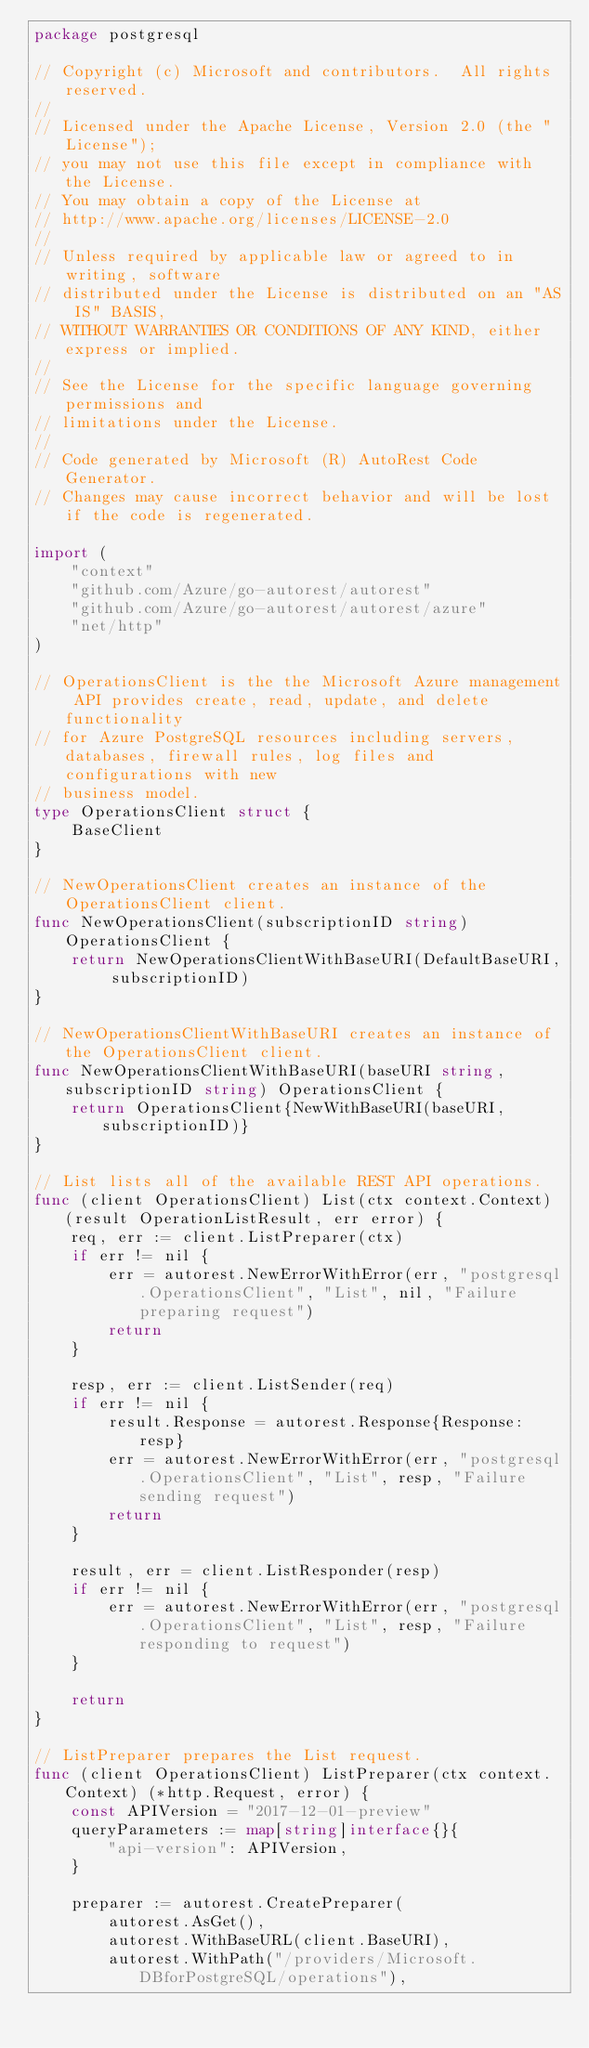Convert code to text. <code><loc_0><loc_0><loc_500><loc_500><_Go_>package postgresql

// Copyright (c) Microsoft and contributors.  All rights reserved.
//
// Licensed under the Apache License, Version 2.0 (the "License");
// you may not use this file except in compliance with the License.
// You may obtain a copy of the License at
// http://www.apache.org/licenses/LICENSE-2.0
//
// Unless required by applicable law or agreed to in writing, software
// distributed under the License is distributed on an "AS IS" BASIS,
// WITHOUT WARRANTIES OR CONDITIONS OF ANY KIND, either express or implied.
//
// See the License for the specific language governing permissions and
// limitations under the License.
//
// Code generated by Microsoft (R) AutoRest Code Generator.
// Changes may cause incorrect behavior and will be lost if the code is regenerated.

import (
	"context"
	"github.com/Azure/go-autorest/autorest"
	"github.com/Azure/go-autorest/autorest/azure"
	"net/http"
)

// OperationsClient is the the Microsoft Azure management API provides create, read, update, and delete functionality
// for Azure PostgreSQL resources including servers, databases, firewall rules, log files and configurations with new
// business model.
type OperationsClient struct {
	BaseClient
}

// NewOperationsClient creates an instance of the OperationsClient client.
func NewOperationsClient(subscriptionID string) OperationsClient {
	return NewOperationsClientWithBaseURI(DefaultBaseURI, subscriptionID)
}

// NewOperationsClientWithBaseURI creates an instance of the OperationsClient client.
func NewOperationsClientWithBaseURI(baseURI string, subscriptionID string) OperationsClient {
	return OperationsClient{NewWithBaseURI(baseURI, subscriptionID)}
}

// List lists all of the available REST API operations.
func (client OperationsClient) List(ctx context.Context) (result OperationListResult, err error) {
	req, err := client.ListPreparer(ctx)
	if err != nil {
		err = autorest.NewErrorWithError(err, "postgresql.OperationsClient", "List", nil, "Failure preparing request")
		return
	}

	resp, err := client.ListSender(req)
	if err != nil {
		result.Response = autorest.Response{Response: resp}
		err = autorest.NewErrorWithError(err, "postgresql.OperationsClient", "List", resp, "Failure sending request")
		return
	}

	result, err = client.ListResponder(resp)
	if err != nil {
		err = autorest.NewErrorWithError(err, "postgresql.OperationsClient", "List", resp, "Failure responding to request")
	}

	return
}

// ListPreparer prepares the List request.
func (client OperationsClient) ListPreparer(ctx context.Context) (*http.Request, error) {
	const APIVersion = "2017-12-01-preview"
	queryParameters := map[string]interface{}{
		"api-version": APIVersion,
	}

	preparer := autorest.CreatePreparer(
		autorest.AsGet(),
		autorest.WithBaseURL(client.BaseURI),
		autorest.WithPath("/providers/Microsoft.DBforPostgreSQL/operations"),</code> 